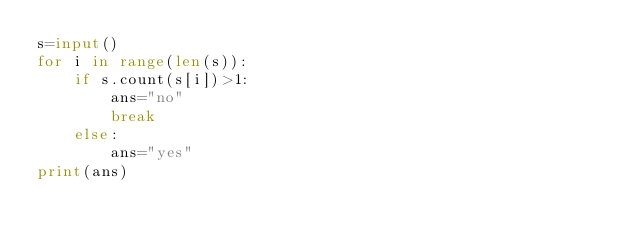<code> <loc_0><loc_0><loc_500><loc_500><_Python_>s=input()
for i in range(len(s)):
    if s.count(s[i])>1:
        ans="no"
        break
    else:
        ans="yes"
print(ans)</code> 